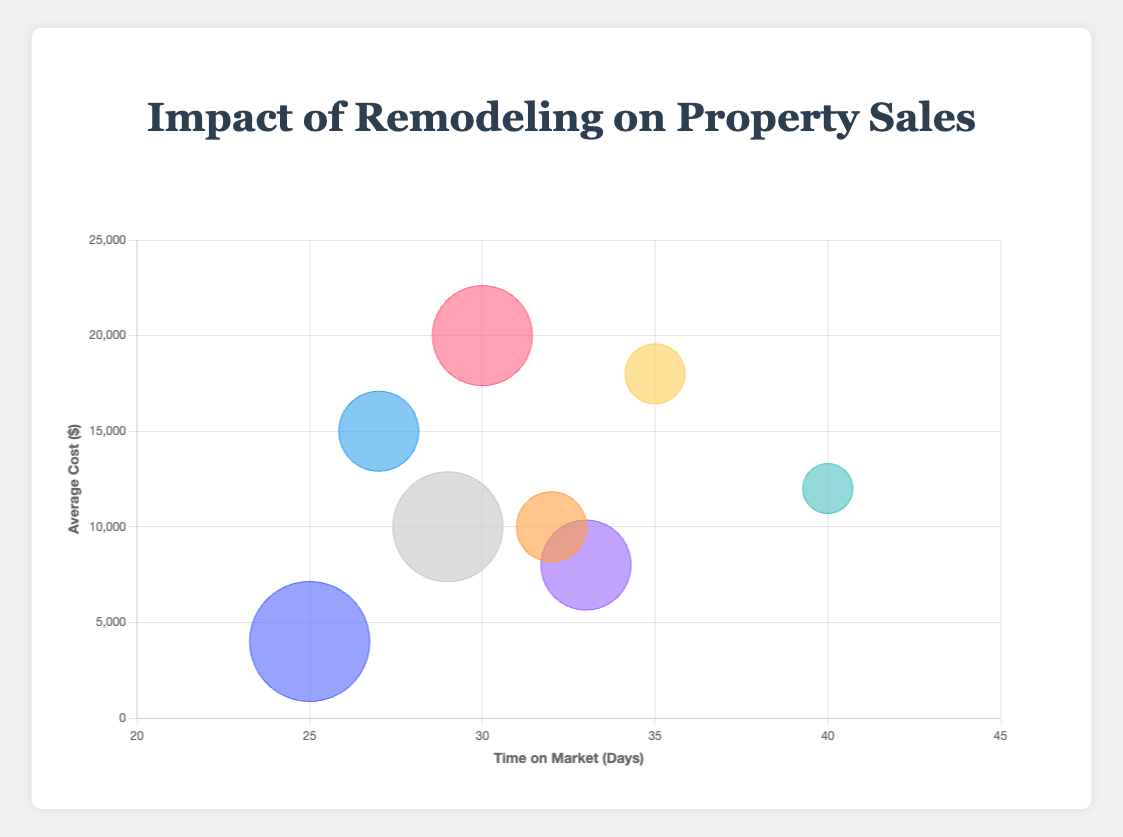What is the title of the chart? The title is displayed at the top of the chart in a larger and bold font. It reads "Impact of Remodeling on Property Sales."
Answer: Impact of Remodeling on Property Sales What is the type of remodeling with the shortest time on market? By observing the x-axis labeled "Time on Market (Days)," the bubble closest to the left (smallest x-value) represents Painting, which has a Time on Market of 25 days.
Answer: Painting How many types of remodeling are represented in the chart? By counting the number of distinct bubbles in the chart, we identify that there are 8 types of remodeling represented.
Answer: 8 Which type of remodeling has the highest average cost? By observing the y-axis labeled "Average Cost ($)," the highest bubble on the y-axis corresponds to Kitchen, which has an average cost of $20,000.
Answer: Kitchen Which type of remodeling has the most number of sales? The size of the bubbles represents the number of sales, with the largest bubble indicating the most sales. The largest bubble represents Painting, with 60 sales.
Answer: Painting What is the average time on market for Kitchen and Bathroom remodels? The time on market for Kitchen is 30 days and for Bathroom is 27 days. The average is (30 + 27) / 2 = 28.5 days.
Answer: 28.5 days Compare the time on market for Basement and Roofing remodels. Which one spends more time on the market? By observing the x-values for Basement (35 days) and Roofing (40 days), Roofing remodels spend more time on the market.
Answer: Roofing Which remodel type has the lowest average cost, and how much is it? By observing the lowest bubble along the y-axis, Painting has the lowest average cost of $4,000.
Answer: Painting, $4,000 What is the relationship between the average cost of remodeling and the time on market based on the chart? Based on the chart, there doesn't appear to be a direct correlation between higher average costs and shorter or longer times on the market. For example, Painting has a low average cost and short time on market, while Roofing has a moderate cost and the longest time on market.
Answer: No direct correlation How does the number of sales for Landscaping compare to Windows remodeling? The size of the bubbles for Landscaping and Windows indicates the number of sales. Landscaping, with a larger bubble, has more sales (45) compared to Windows (35).
Answer: Landscaping has more sales (45 vs 35) 